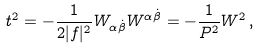Convert formula to latex. <formula><loc_0><loc_0><loc_500><loc_500>t ^ { 2 } = - \frac { 1 } { 2 | f | ^ { 2 } } W _ { \alpha \dot { \beta } } W ^ { \alpha \dot { \beta } } = - \frac { 1 } { P ^ { 2 } } W ^ { 2 } \, ,</formula> 